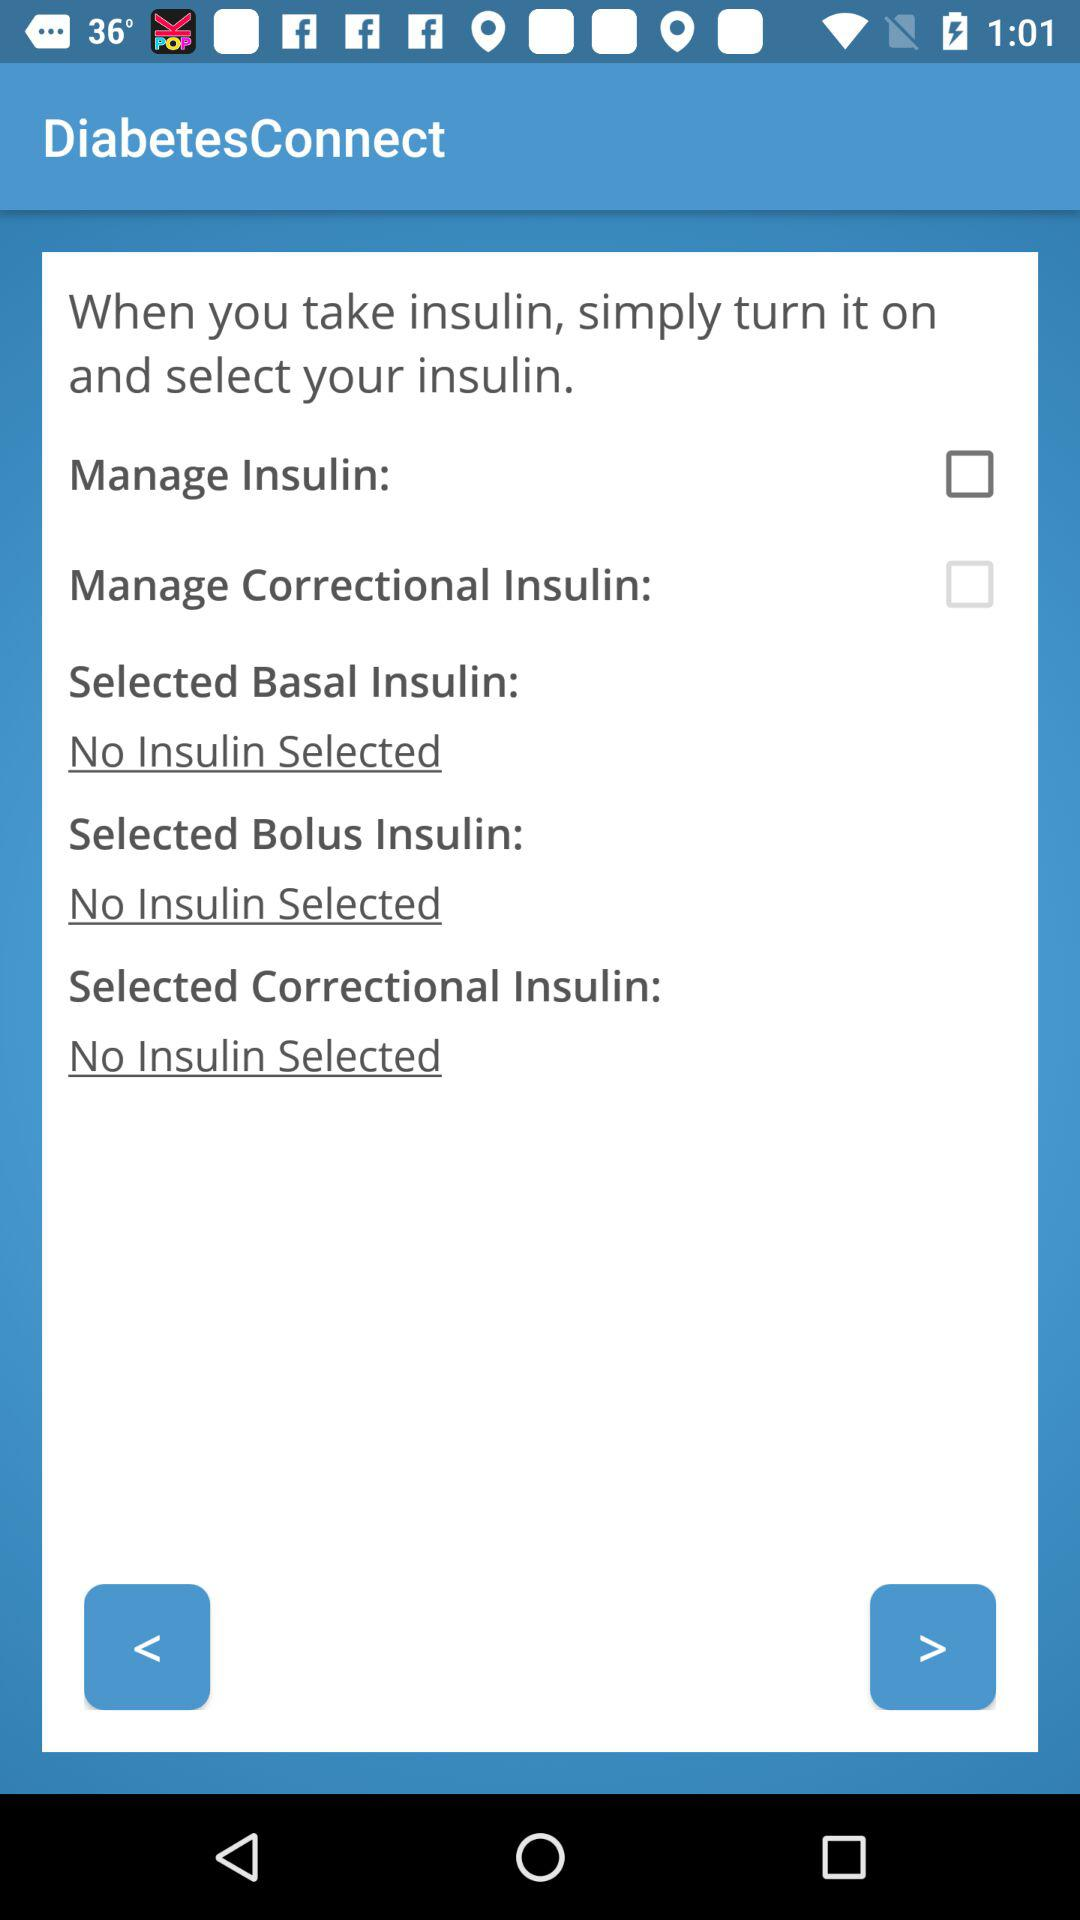What is the name of the application? The name of the application is "DiabetesConnect". 